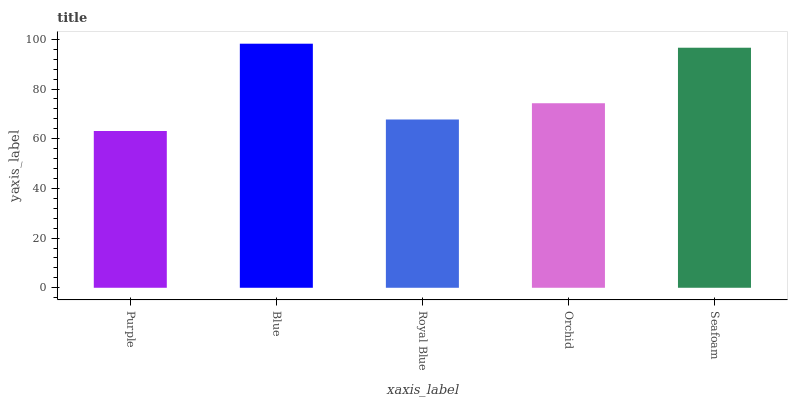Is Purple the minimum?
Answer yes or no. Yes. Is Blue the maximum?
Answer yes or no. Yes. Is Royal Blue the minimum?
Answer yes or no. No. Is Royal Blue the maximum?
Answer yes or no. No. Is Blue greater than Royal Blue?
Answer yes or no. Yes. Is Royal Blue less than Blue?
Answer yes or no. Yes. Is Royal Blue greater than Blue?
Answer yes or no. No. Is Blue less than Royal Blue?
Answer yes or no. No. Is Orchid the high median?
Answer yes or no. Yes. Is Orchid the low median?
Answer yes or no. Yes. Is Purple the high median?
Answer yes or no. No. Is Royal Blue the low median?
Answer yes or no. No. 